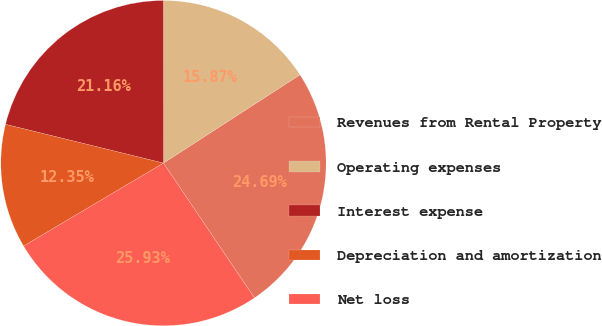Convert chart. <chart><loc_0><loc_0><loc_500><loc_500><pie_chart><fcel>Revenues from Rental Property<fcel>Operating expenses<fcel>Interest expense<fcel>Depreciation and amortization<fcel>Net loss<nl><fcel>24.69%<fcel>15.87%<fcel>21.16%<fcel>12.35%<fcel>25.93%<nl></chart> 